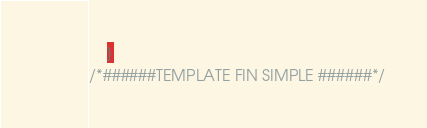Convert code to text. <code><loc_0><loc_0><loc_500><loc_500><_CSS_>    }
/*######TEMPLATE FIN SIMPLE ######*/
</code> 